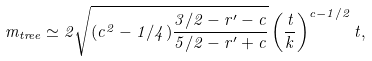<formula> <loc_0><loc_0><loc_500><loc_500>m _ { t r e e } \simeq 2 \sqrt { ( c ^ { 2 } - 1 / 4 ) \frac { 3 / 2 - r ^ { \prime } - c } { 5 / 2 - r ^ { \prime } + c } } \left ( \frac { t } { k } \right ) ^ { c - 1 / 2 } t ,</formula> 